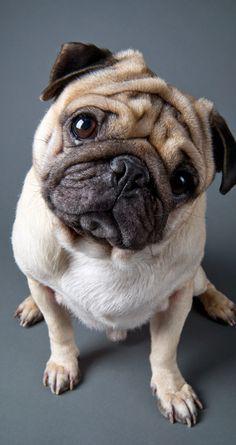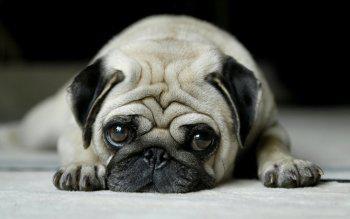The first image is the image on the left, the second image is the image on the right. For the images shown, is this caption "At least one pug is wearing somehing on its neck." true? Answer yes or no. No. The first image is the image on the left, the second image is the image on the right. For the images displayed, is the sentence "The left image shows one pug reclining on its belly with its front paws forward and its head upright." factually correct? Answer yes or no. No. 